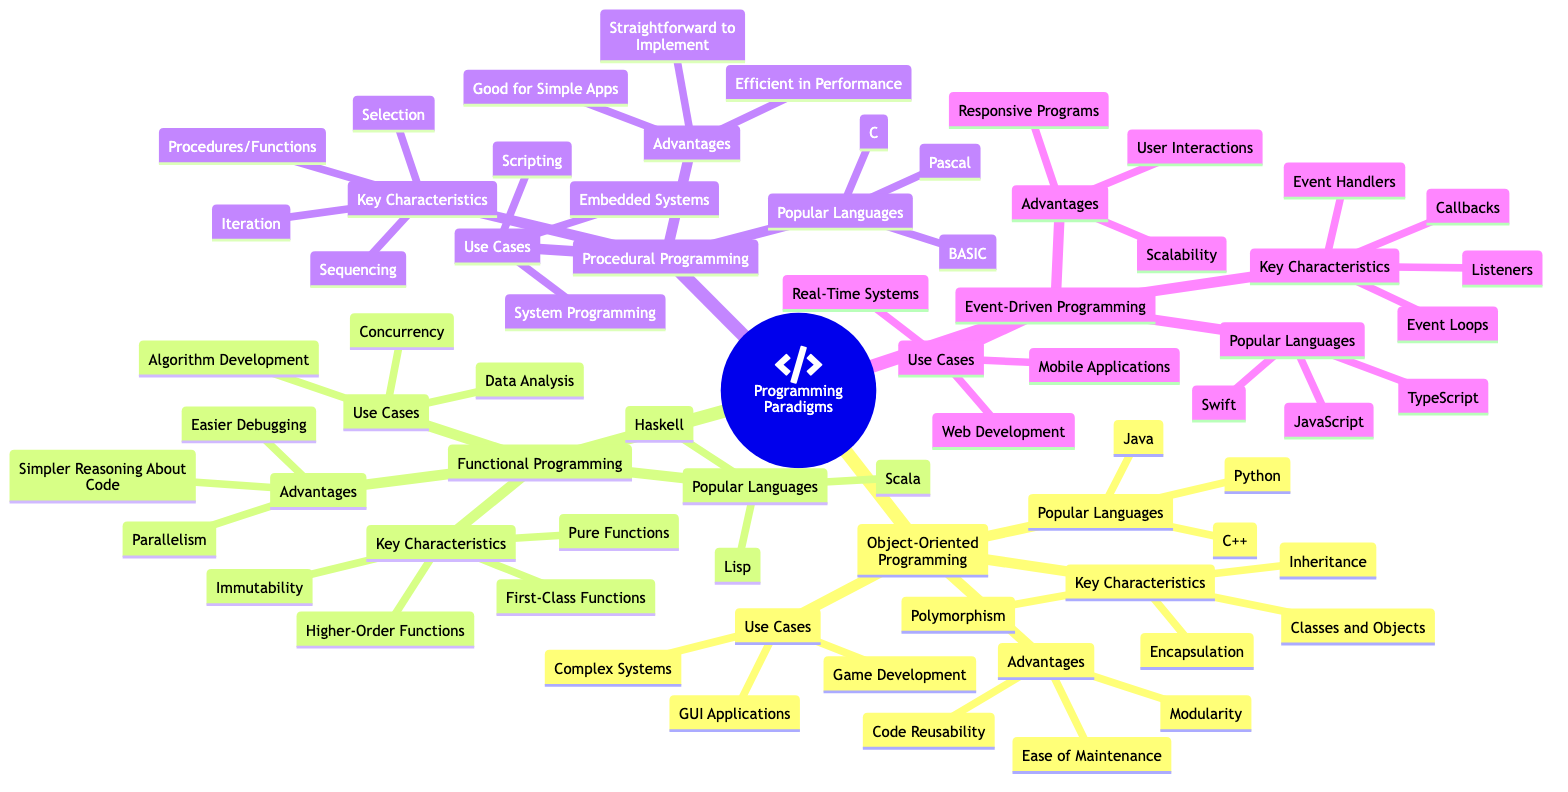What are the key characteristics of Object-Oriented Programming? According to the diagram, the key characteristics of Object-Oriented Programming include Classes and Objects, Encapsulation, Inheritance, and Polymorphism.
Answer: Classes and Objects, Encapsulation, Inheritance, Polymorphism How many programming paradigms are listed in the diagram? The diagram contains four programming paradigms: Object-Oriented Programming, Functional Programming, Procedural Programming, and Event-Driven Programming. Counted together, they amount to four.
Answer: 4 What is a common use case for Functional Programming? The diagram indicates that Data Analysis is one of the use cases listed for Functional Programming. Thus, it is a common use case.
Answer: Data Analysis Which paradigm emphasizes user interactions? The diagram specifies that Event-Driven Programming has advantages that cater to User Interactions, implying it emphasizes this aspect.
Answer: Event-Driven Programming What advantages does Procedural Programming provide? From the diagram, the advantages of Procedural Programming are: Straightforward to Implement, Efficient in Terms of Performance, and Good for Simple Apps. These three advantages can be directly read from the diagram.
Answer: Straightforward to Implement, Efficient in Terms of Performance, Good for Simple Apps Which paradigm is associated with JavaScript? The diagram indicates that JavaScript is a popular language for Event-Driven Programming, linking the language specifically to that paradigm.
Answer: Event-Driven Programming Which programming paradigm includes Higher-Order Functions as a key characteristic? By examining the diagram, it is clear that Functional Programming features Higher-Order Functions among its key characteristics.
Answer: Functional Programming What are the popular languages for Object-Oriented Programming? According to the diagram, the popular languages for Object-Oriented Programming are Java, C++, and Python, showing a direct connection from this paradigm to the specified languages.
Answer: Java, C++, Python 